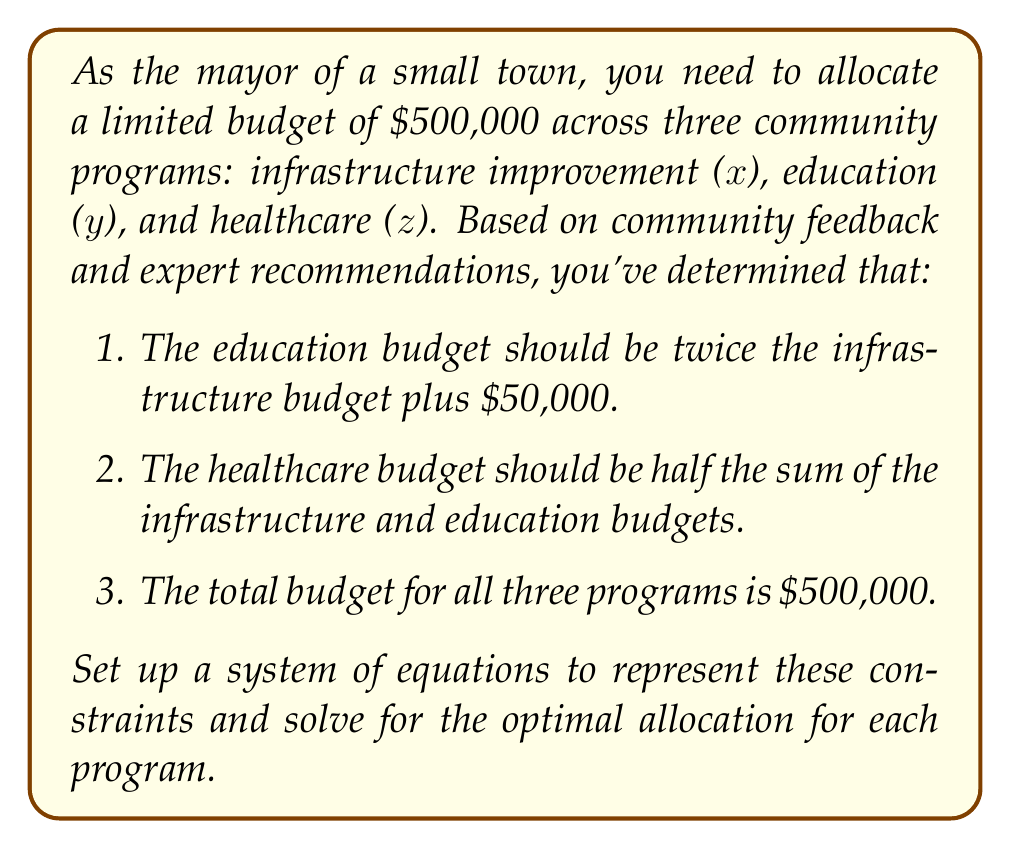Provide a solution to this math problem. Let's approach this step-by-step:

1. First, we'll set up the system of equations based on the given information:

   $$\begin{cases}
   y = 2x + 50,000 & \text{(Education budget constraint)}\\
   z = \frac{1}{2}(x + y) & \text{(Healthcare budget constraint)}\\
   x + y + z = 500,000 & \text{(Total budget constraint)}
   \end{cases}$$

2. We can simplify this system by substituting the first equation into the second and third:

   $$\begin{cases}
   y = 2x + 50,000\\
   z = \frac{1}{2}(x + (2x + 50,000)) = \frac{3x + 50,000}{2}\\
   x + (2x + 50,000) + \frac{3x + 50,000}{2} = 500,000
   \end{cases}$$

3. Now, let's focus on solving the third equation:

   $$x + 2x + 50,000 + \frac{3x + 50,000}{2} = 500,000$$

4. Multiply both sides by 2 to eliminate fractions:

   $$2x + 4x + 100,000 + 3x + 50,000 = 1,000,000$$

5. Combine like terms:

   $$9x + 150,000 = 1,000,000$$

6. Subtract 150,000 from both sides:

   $$9x = 850,000$$

7. Divide both sides by 9:

   $$x = 94,444.44$$

8. Now that we have x, we can solve for y and z:

   $$y = 2(94,444.44) + 50,000 = 238,888.88$$
   $$z = \frac{1}{2}(94,444.44 + 238,888.88) = 166,666.66$$

9. Round to the nearest dollar for practical purposes.
Answer: The optimal allocation for each program is:
Infrastructure (x): $94,444
Education (y): $238,889
Healthcare (z): $166,667 